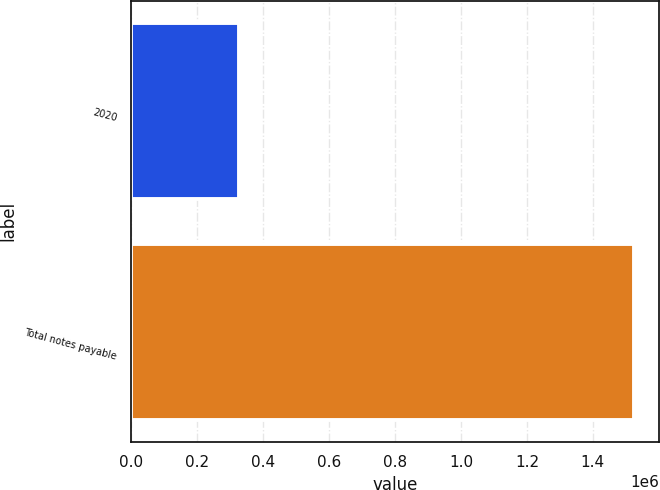Convert chart. <chart><loc_0><loc_0><loc_500><loc_500><bar_chart><fcel>2020<fcel>Total notes payable<nl><fcel>326583<fcel>1.52371e+06<nl></chart> 